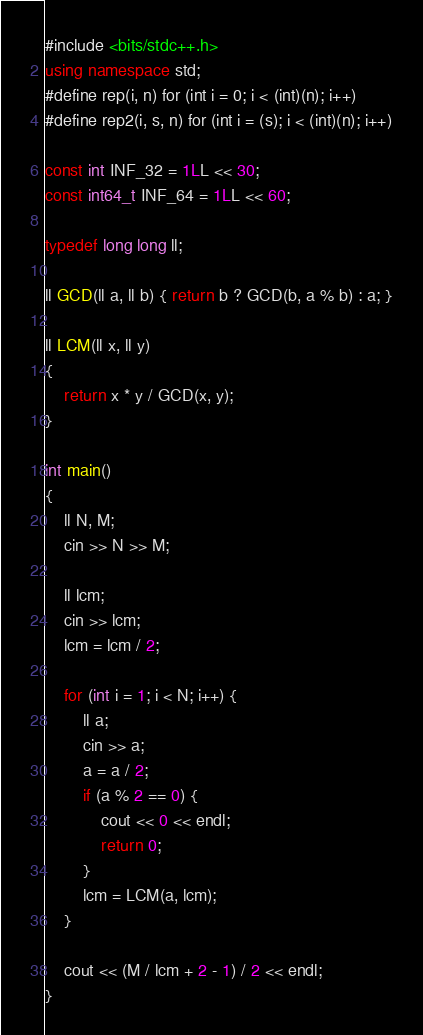<code> <loc_0><loc_0><loc_500><loc_500><_C++_>#include <bits/stdc++.h>
using namespace std;
#define rep(i, n) for (int i = 0; i < (int)(n); i++)
#define rep2(i, s, n) for (int i = (s); i < (int)(n); i++)

const int INF_32 = 1LL << 30;
const int64_t INF_64 = 1LL << 60;

typedef long long ll;

ll GCD(ll a, ll b) { return b ? GCD(b, a % b) : a; }

ll LCM(ll x, ll y)
{
    return x * y / GCD(x, y);
}

int main()
{
    ll N, M;
    cin >> N >> M;

    ll lcm;
    cin >> lcm;
    lcm = lcm / 2;

    for (int i = 1; i < N; i++) {
        ll a;
        cin >> a;
        a = a / 2;
        if (a % 2 == 0) {
            cout << 0 << endl;
            return 0;
        }
        lcm = LCM(a, lcm);
    }

    cout << (M / lcm + 2 - 1) / 2 << endl;
}
</code> 